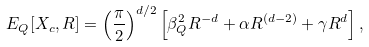<formula> <loc_0><loc_0><loc_500><loc_500>E _ { Q } [ X _ { c } , R ] = \left ( \frac { \pi } { 2 } \right ) ^ { d / 2 } \left [ \beta _ { Q } ^ { 2 } R ^ { - d } + \alpha R ^ { ( d - 2 ) } + \gamma R ^ { d } \right ] ,</formula> 